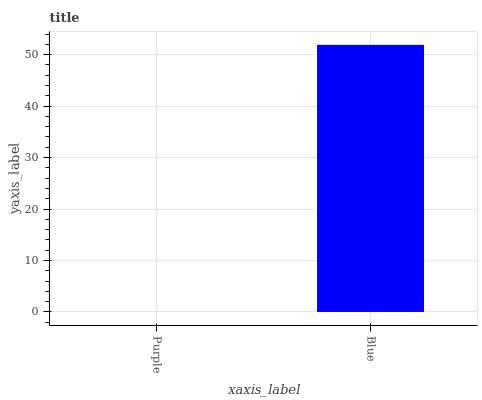Is Purple the minimum?
Answer yes or no. Yes. Is Blue the maximum?
Answer yes or no. Yes. Is Blue the minimum?
Answer yes or no. No. Is Blue greater than Purple?
Answer yes or no. Yes. Is Purple less than Blue?
Answer yes or no. Yes. Is Purple greater than Blue?
Answer yes or no. No. Is Blue less than Purple?
Answer yes or no. No. Is Blue the high median?
Answer yes or no. Yes. Is Purple the low median?
Answer yes or no. Yes. Is Purple the high median?
Answer yes or no. No. Is Blue the low median?
Answer yes or no. No. 